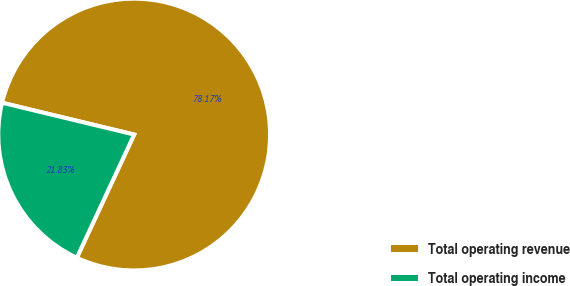Convert chart to OTSL. <chart><loc_0><loc_0><loc_500><loc_500><pie_chart><fcel>Total operating revenue<fcel>Total operating income<nl><fcel>78.17%<fcel>21.83%<nl></chart> 